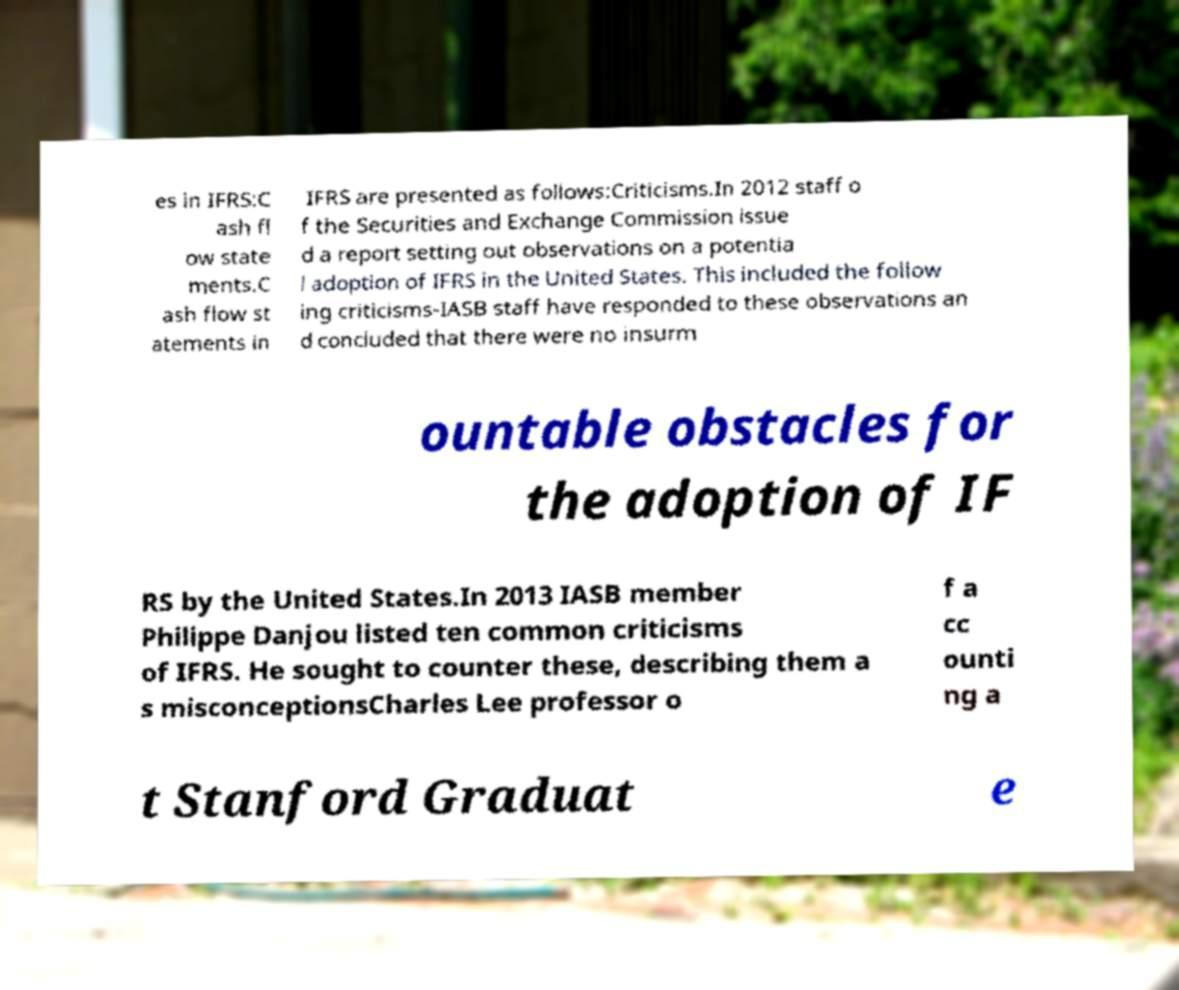Can you accurately transcribe the text from the provided image for me? es in IFRS:C ash fl ow state ments.C ash flow st atements in IFRS are presented as follows:Criticisms.In 2012 staff o f the Securities and Exchange Commission issue d a report setting out observations on a potentia l adoption of IFRS in the United States. This included the follow ing criticisms-IASB staff have responded to these observations an d concluded that there were no insurm ountable obstacles for the adoption of IF RS by the United States.In 2013 IASB member Philippe Danjou listed ten common criticisms of IFRS. He sought to counter these, describing them a s misconceptionsCharles Lee professor o f a cc ounti ng a t Stanford Graduat e 